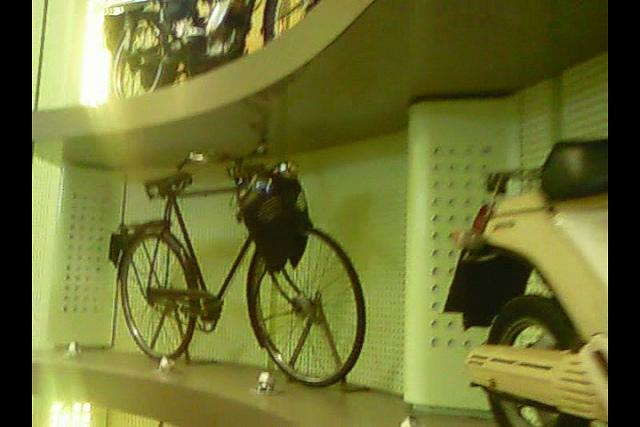What mode of transportation is featured? bicycle 